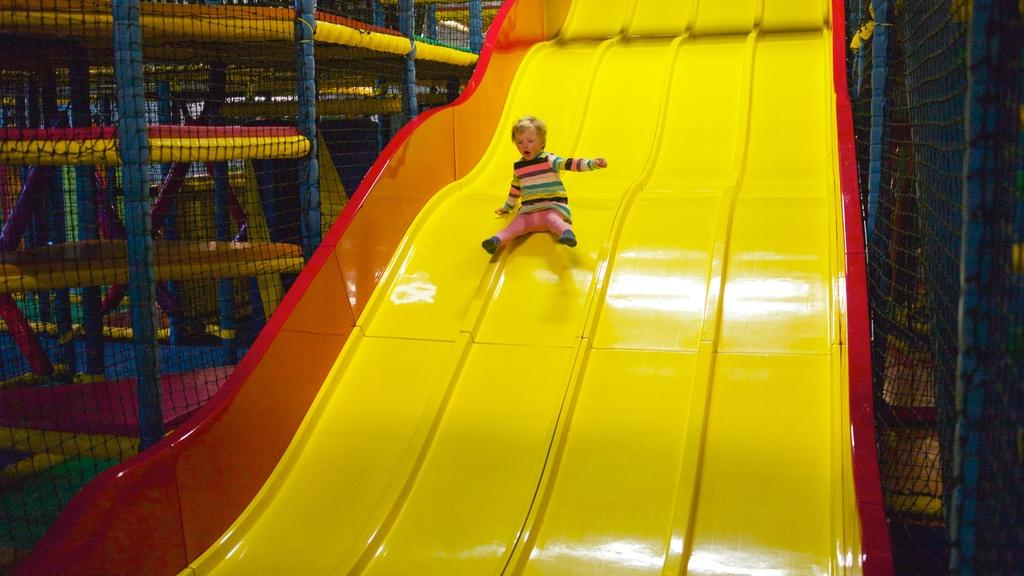What is the main subject of the image? The main subject of the image is a kid. What is the kid doing in the image? The kid is sliding on a slider. What else can be seen in the image besides the kid? There is a net and other playing objects in the image. What scientific experiment is being conducted in the image? There is no scientific experiment being conducted in the image; it shows a kid sliding on a slider and other playing objects. 